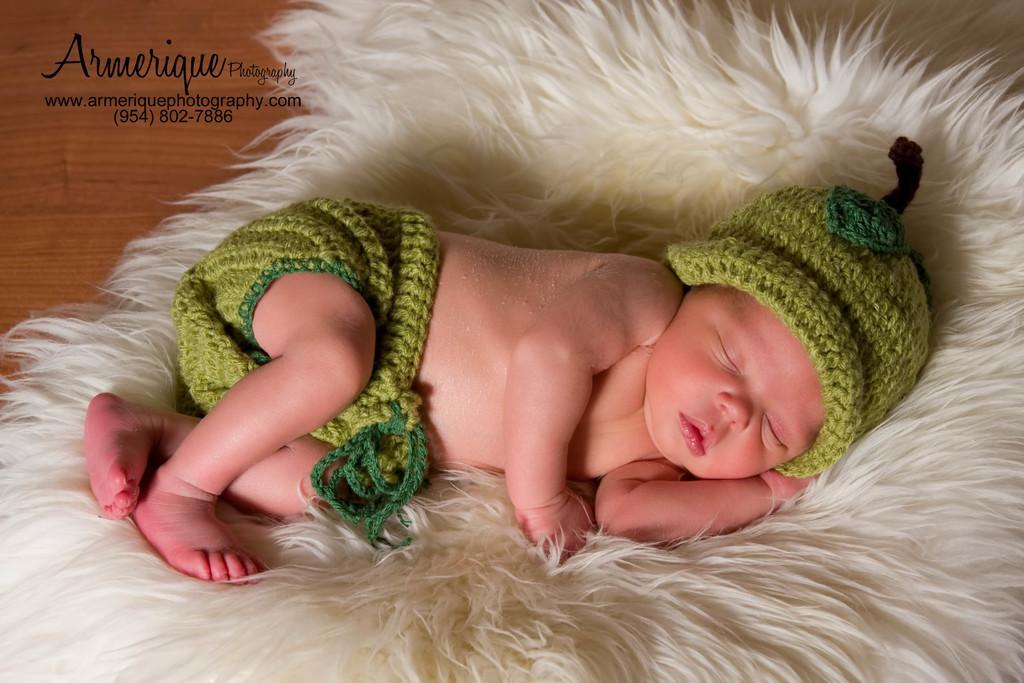Could you give a brief overview of what you see in this image? In the center of the image we can see baby sleeping on the fur. At the top left corner we can see text. 